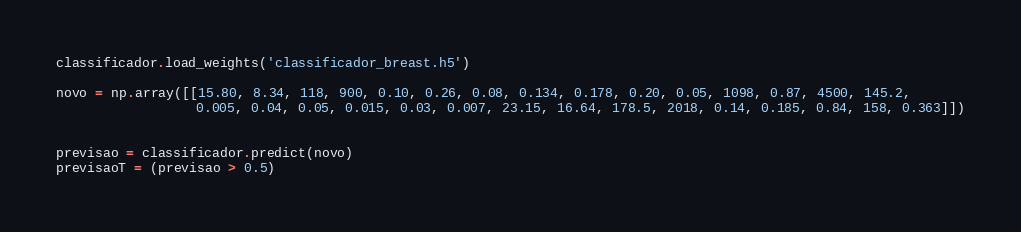<code> <loc_0><loc_0><loc_500><loc_500><_Python_>classificador.load_weights('classificador_breast.h5')

novo = np.array([[15.80, 8.34, 118, 900, 0.10, 0.26, 0.08, 0.134, 0.178, 0.20, 0.05, 1098, 0.87, 4500, 145.2,
                  0.005, 0.04, 0.05, 0.015, 0.03, 0.007, 23.15, 16.64, 178.5, 2018, 0.14, 0.185, 0.84, 158, 0.363]])
 

previsao = classificador.predict(novo)
previsaoT = (previsao > 0.5)</code> 